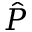<formula> <loc_0><loc_0><loc_500><loc_500>\hat { P }</formula> 